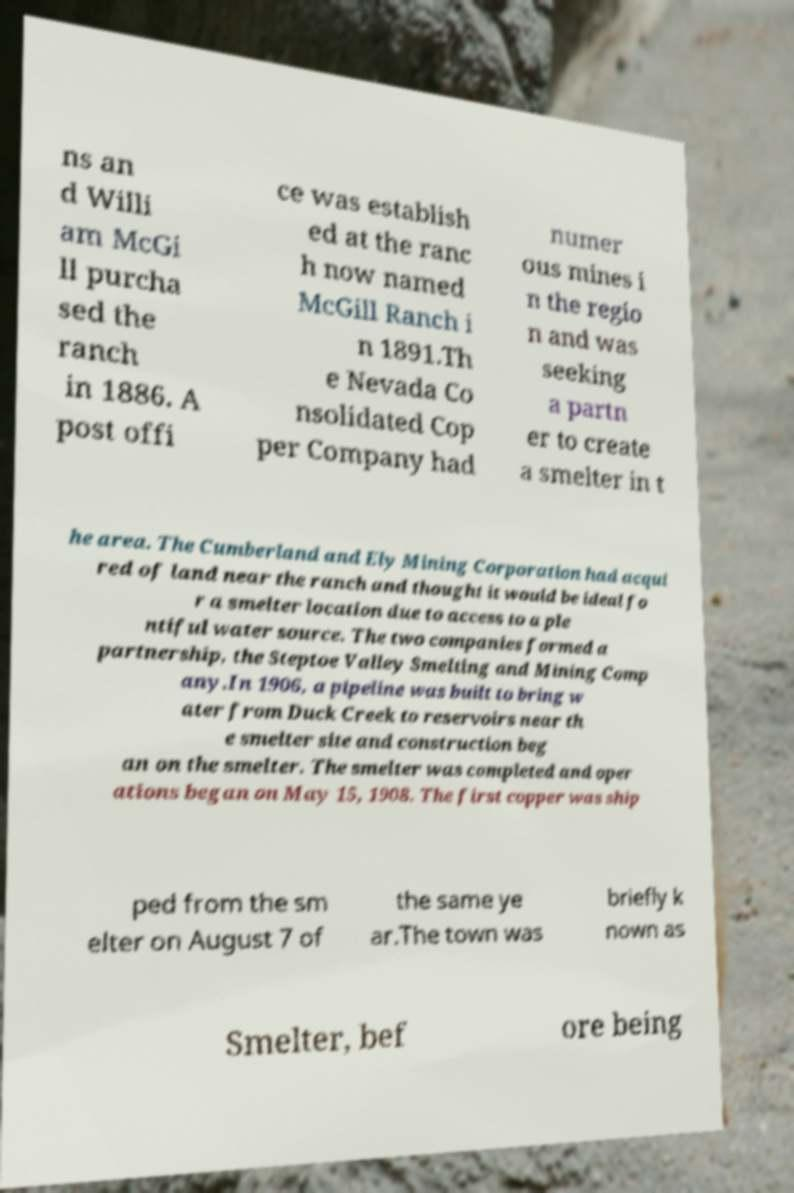There's text embedded in this image that I need extracted. Can you transcribe it verbatim? ns an d Willi am McGi ll purcha sed the ranch in 1886. A post offi ce was establish ed at the ranc h now named McGill Ranch i n 1891.Th e Nevada Co nsolidated Cop per Company had numer ous mines i n the regio n and was seeking a partn er to create a smelter in t he area. The Cumberland and Ely Mining Corporation had acqui red of land near the ranch and thought it would be ideal fo r a smelter location due to access to a ple ntiful water source. The two companies formed a partnership, the Steptoe Valley Smelting and Mining Comp any.In 1906, a pipeline was built to bring w ater from Duck Creek to reservoirs near th e smelter site and construction beg an on the smelter. The smelter was completed and oper ations began on May 15, 1908. The first copper was ship ped from the sm elter on August 7 of the same ye ar.The town was briefly k nown as Smelter, bef ore being 